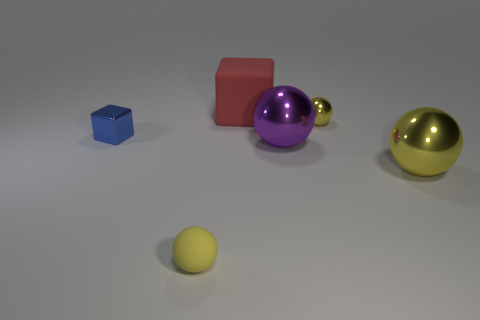There is a big ball behind the large yellow object that is right of the tiny yellow shiny thing; is there a blue shiny thing on the right side of it?
Make the answer very short. No. Do the yellow rubber thing and the blue metal block have the same size?
Your answer should be compact. Yes. There is a ball in front of the metallic object right of the small yellow thing behind the blue block; what color is it?
Offer a terse response. Yellow. How many large shiny objects are the same color as the tiny shiny ball?
Offer a terse response. 1. How many small objects are either red matte balls or purple objects?
Provide a succinct answer. 0. Is there a big red rubber thing that has the same shape as the blue metallic object?
Your answer should be very brief. Yes. Does the red object have the same shape as the blue object?
Provide a short and direct response. Yes. What color is the small metal object to the right of the tiny sphere that is to the left of the big red object?
Your response must be concise. Yellow. What color is the block that is the same size as the yellow matte thing?
Provide a short and direct response. Blue. How many matte objects are either yellow blocks or large purple balls?
Ensure brevity in your answer.  0. 